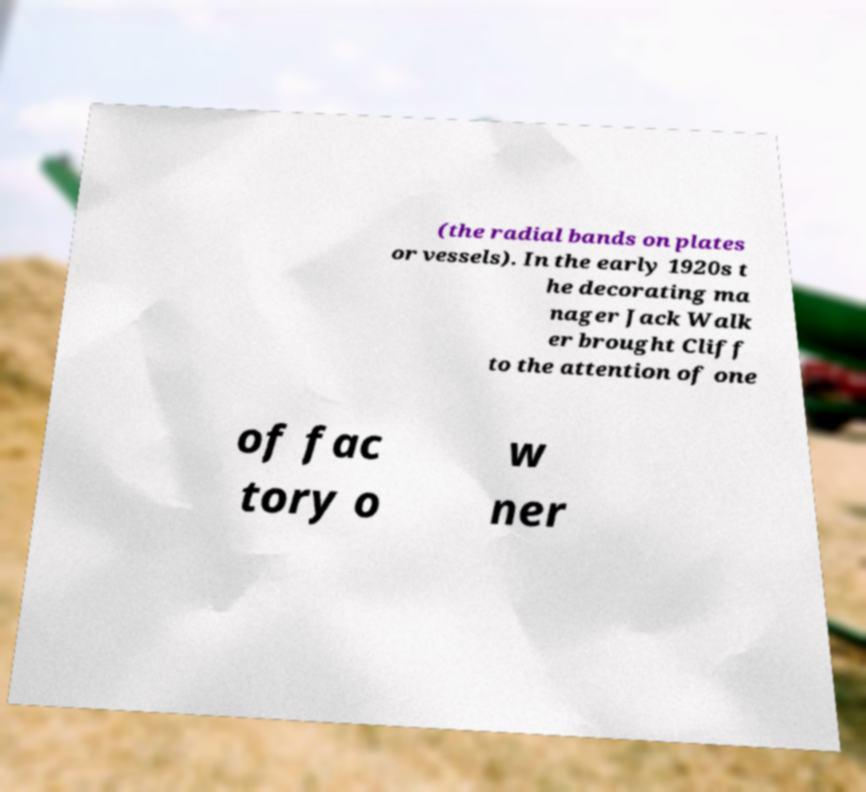Can you accurately transcribe the text from the provided image for me? (the radial bands on plates or vessels). In the early 1920s t he decorating ma nager Jack Walk er brought Cliff to the attention of one of fac tory o w ner 